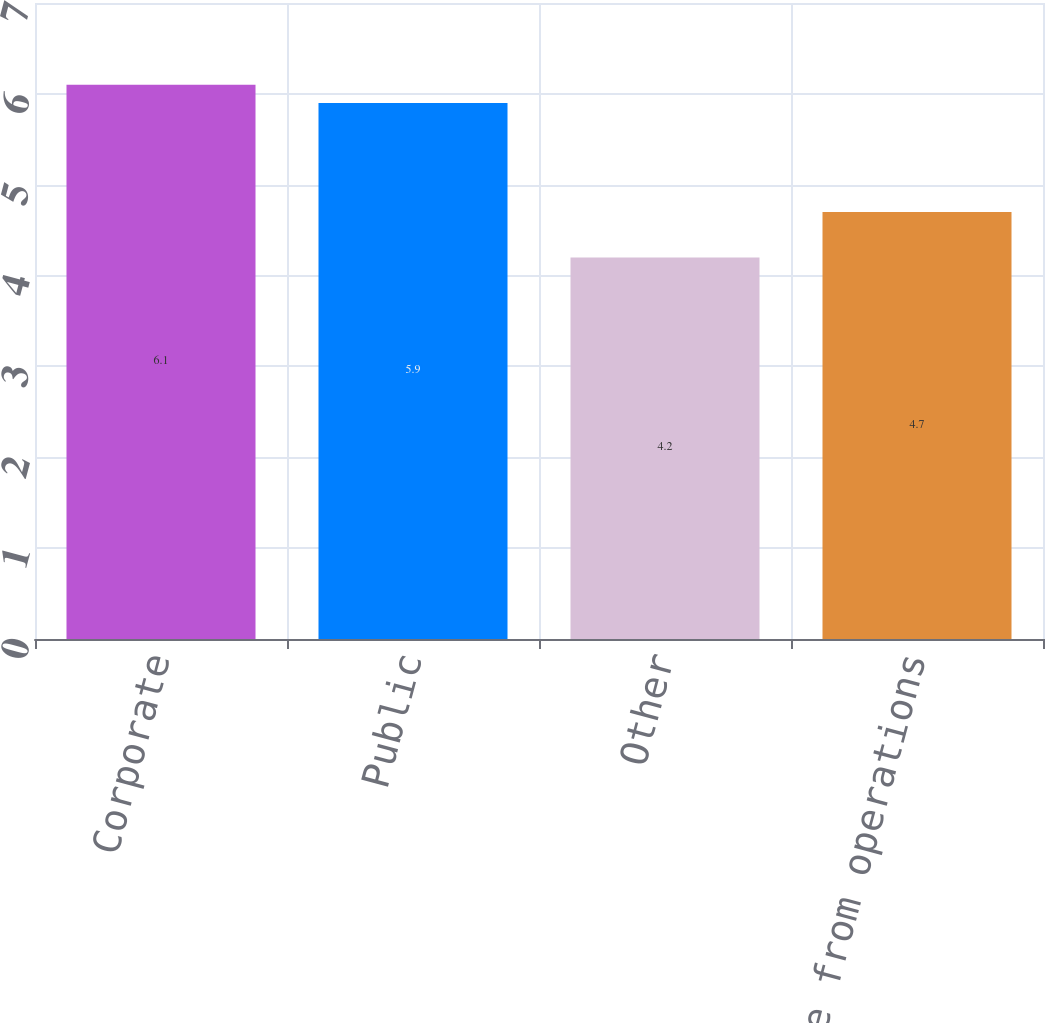Convert chart. <chart><loc_0><loc_0><loc_500><loc_500><bar_chart><fcel>Corporate<fcel>Public<fcel>Other<fcel>Total Income from operations<nl><fcel>6.1<fcel>5.9<fcel>4.2<fcel>4.7<nl></chart> 